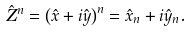<formula> <loc_0><loc_0><loc_500><loc_500>\hat { Z } ^ { n } = \left ( \hat { x } + i \hat { y } \right ) ^ { n } = \hat { x } _ { n } + i \hat { y } _ { n } .</formula> 